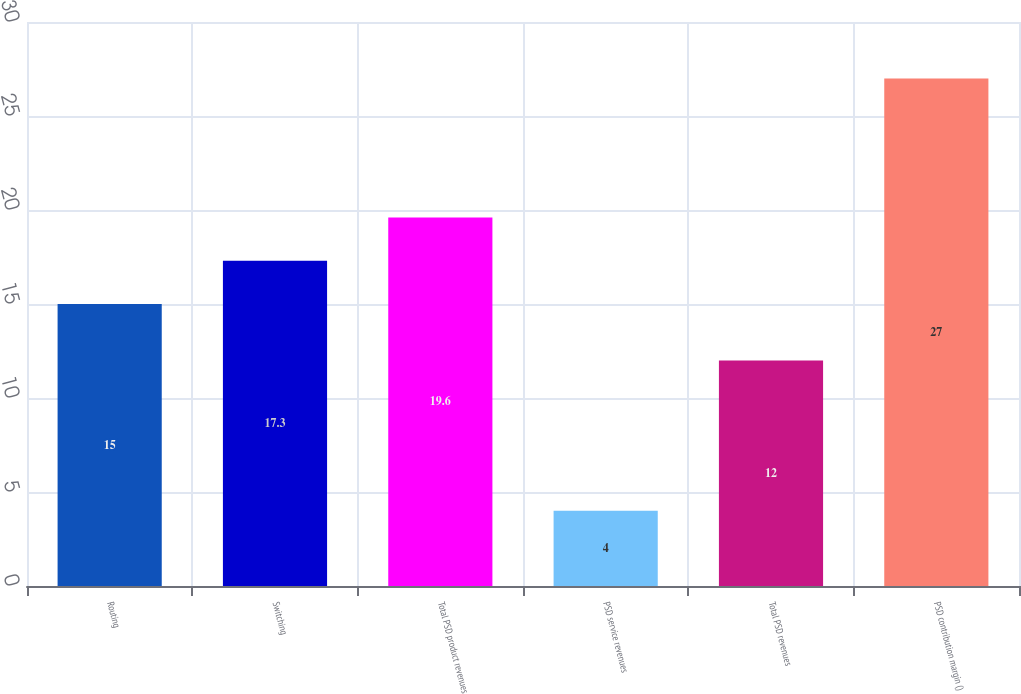Convert chart. <chart><loc_0><loc_0><loc_500><loc_500><bar_chart><fcel>Routing<fcel>Switching<fcel>Total PSD product revenues<fcel>PSD service revenues<fcel>Total PSD revenues<fcel>PSD contribution margin ()<nl><fcel>15<fcel>17.3<fcel>19.6<fcel>4<fcel>12<fcel>27<nl></chart> 